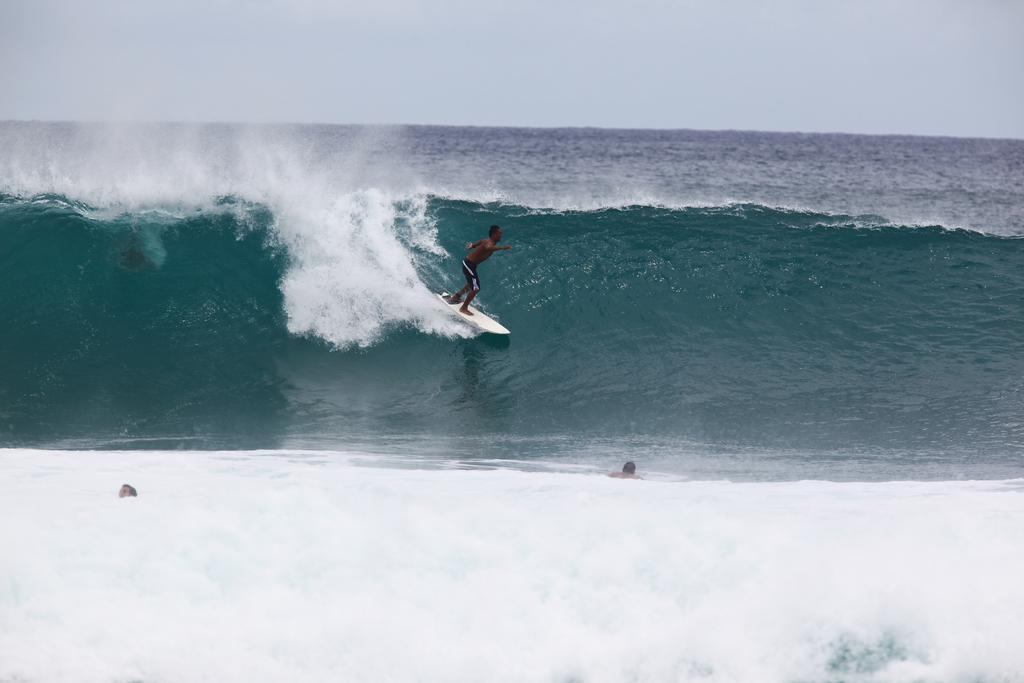What are the two persons in the image doing? They are in the water, with one person surfing on the water. What can be seen in the background of the image? The sky and water are visible in the background of the image. What type of apparatus is being used by the person surfing in the image? There is no apparatus visible in the image; the person is surfing on the water without any additional equipment. What kind of oatmeal can be seen in the image? There is no oatmeal present in the image. What type of skirt is the person wearing in the image? There is no skirt visible in the image; both persons are in the water, and their clothing is not discernible. 